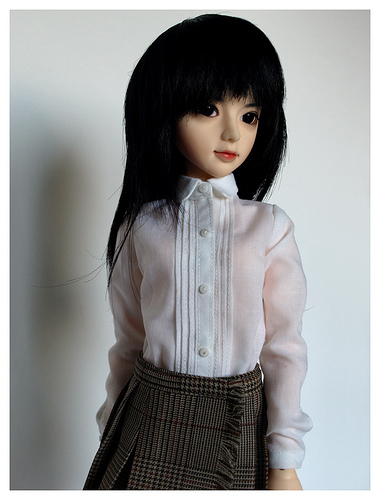<image>
Is the doll in the shirt? Yes. The doll is contained within or inside the shirt, showing a containment relationship. 